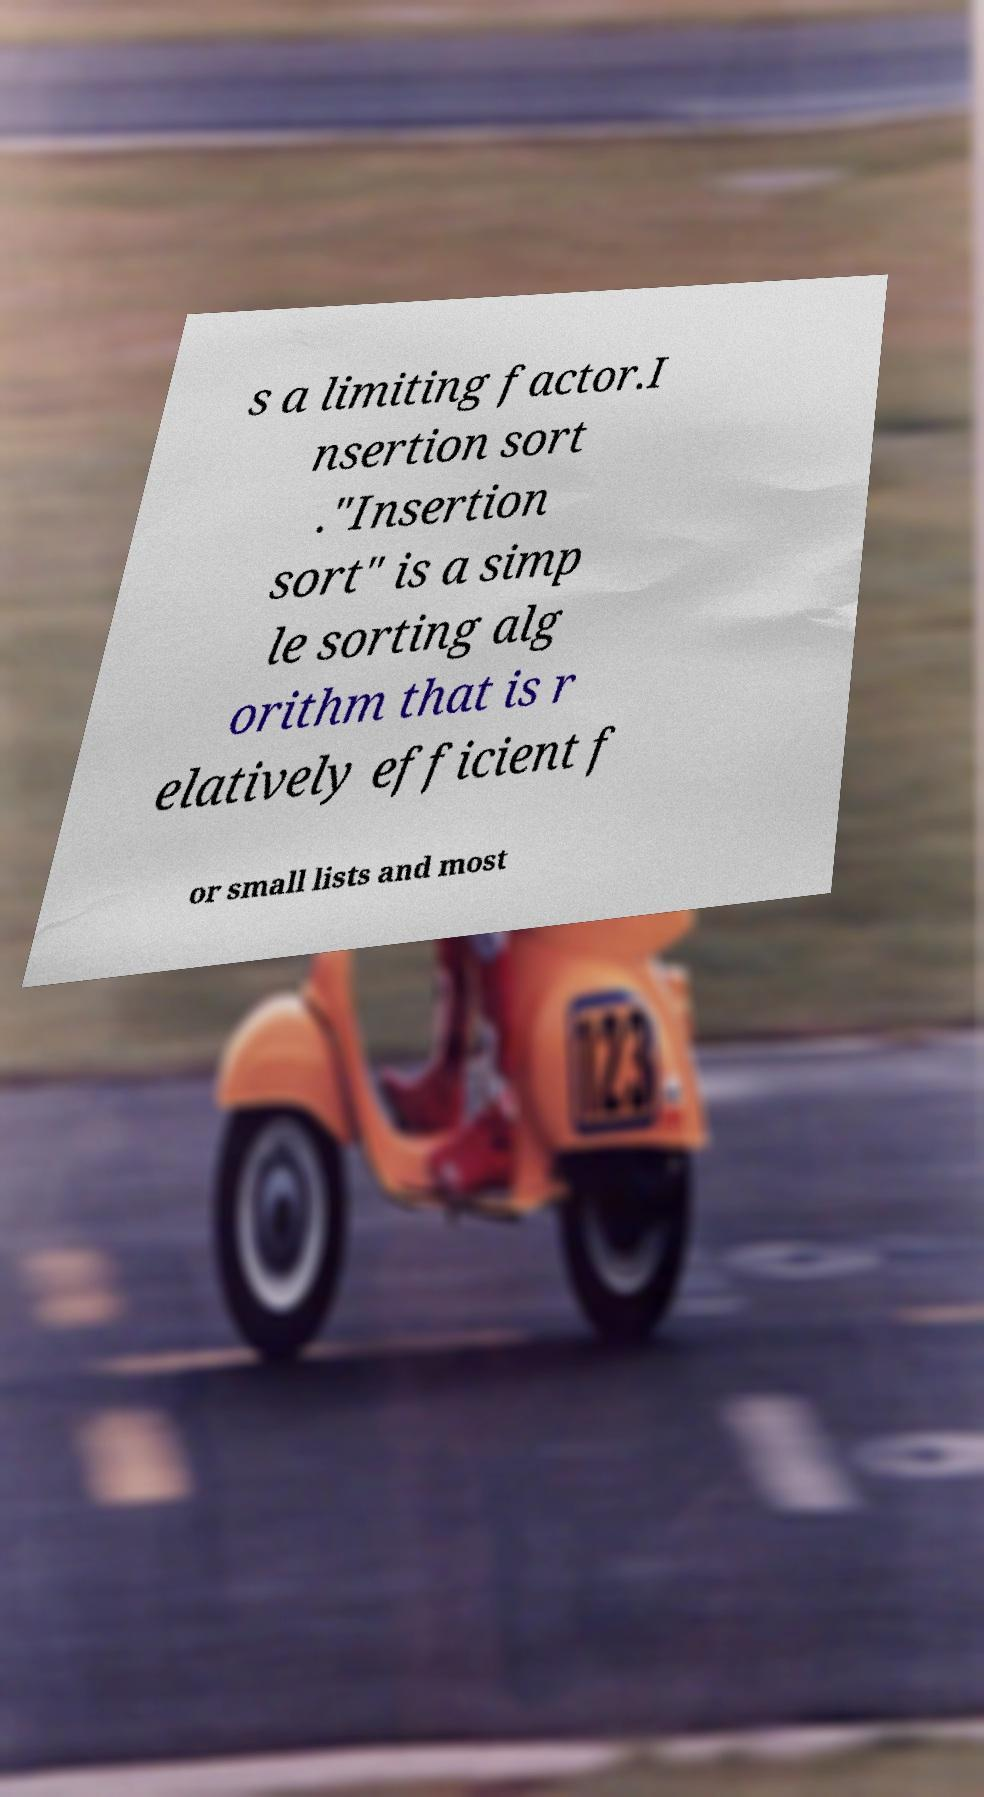Please read and relay the text visible in this image. What does it say? s a limiting factor.I nsertion sort ."Insertion sort" is a simp le sorting alg orithm that is r elatively efficient f or small lists and most 